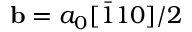Convert formula to latex. <formula><loc_0><loc_0><loc_500><loc_500>b = a _ { 0 } [ \bar { 1 } 1 0 ] / 2</formula> 